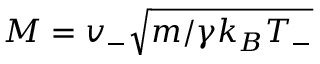Convert formula to latex. <formula><loc_0><loc_0><loc_500><loc_500>M = v _ { - } \sqrt { m / \gamma k _ { B } T _ { - } }</formula> 